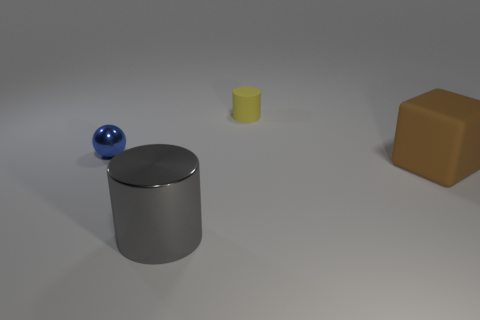What materials do these objects appear to be made of? The objects in the image appear to be rendered with different materials. The cube looks like it might be made of a matte plastic or wood-based material, the cylinder has a matte metallic finish, and the sphere has a glossy metallic surface, reflecting the environment. 